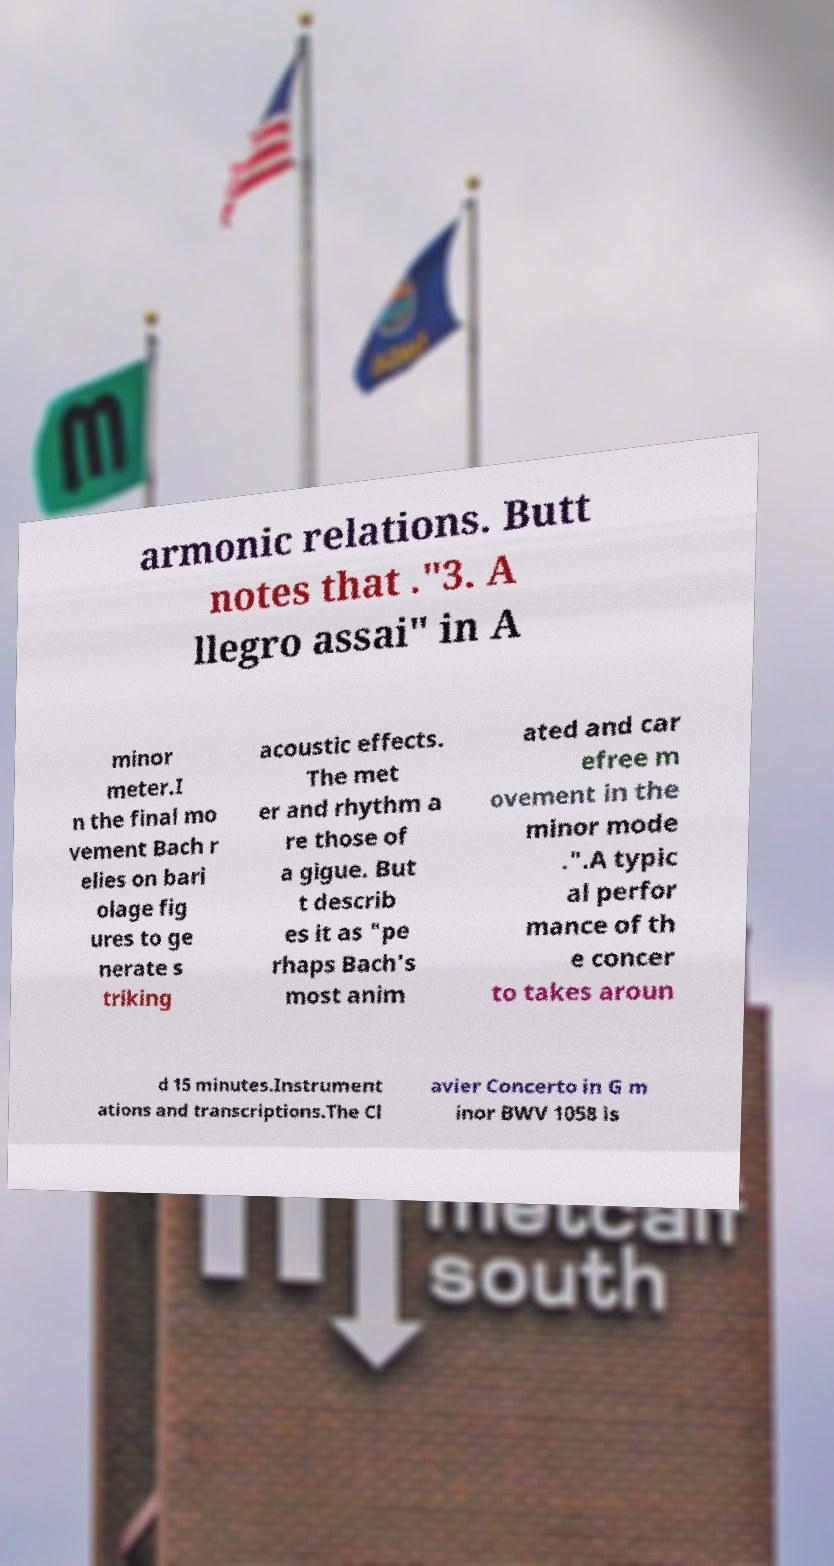Can you read and provide the text displayed in the image?This photo seems to have some interesting text. Can you extract and type it out for me? armonic relations. Butt notes that ."3. A llegro assai" in A minor meter.I n the final mo vement Bach r elies on bari olage fig ures to ge nerate s triking acoustic effects. The met er and rhythm a re those of a gigue. But t describ es it as "pe rhaps Bach's most anim ated and car efree m ovement in the minor mode .".A typic al perfor mance of th e concer to takes aroun d 15 minutes.Instrument ations and transcriptions.The Cl avier Concerto in G m inor BWV 1058 is 